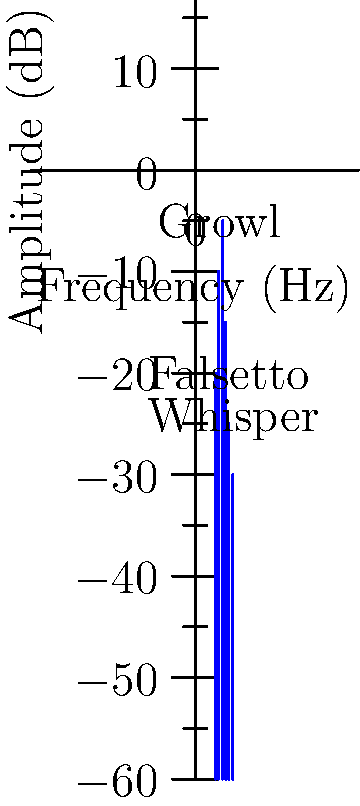Analyze the spectrogram of Kid Bookie's vocal performance. Which vocal technique is represented by the peak at approximately 200 Hz, and how does this relate to his signature sound? To analyze the spectrogram and identify Kid Bookie's vocal technique:

1. Observe the frequency spectrum: The x-axis represents frequency in Hz, and the y-axis represents amplitude in dB.

2. Locate the peak at 200 Hz: This peak has the second-highest amplitude in the spectrum.

3. Identify the vocal technique: The label "Growl" is associated with this peak, indicating that the 200 Hz frequency corresponds to Kid Bookie's growl technique.

4. Understand the growl technique: Growling is a vocal effect that adds a rough, gritty texture to the voice by engaging the false vocal folds.

5. Relate to Kid Bookie's signature sound:
   a) Kid Bookie is known for blending rap and rock styles.
   b) The growl technique is common in rock and metal vocals.
   c) By incorporating growls, Kid Bookie adds aggression and intensity to his rap delivery.

6. Compare to other techniques:
   a) Falsetto (2000 Hz): Higher frequency, typical for softer, higher-pitched vocals.
   b) Whisper (5000 Hz): Highest frequency shown, representing breathy, quiet sounds.

7. Conclude: The growl technique at 200 Hz contributes significantly to Kid Bookie's unique vocal style, merging rap and rock elements to create his signature sound.
Answer: Growl technique, adding aggression and rock elements to his rap style. 